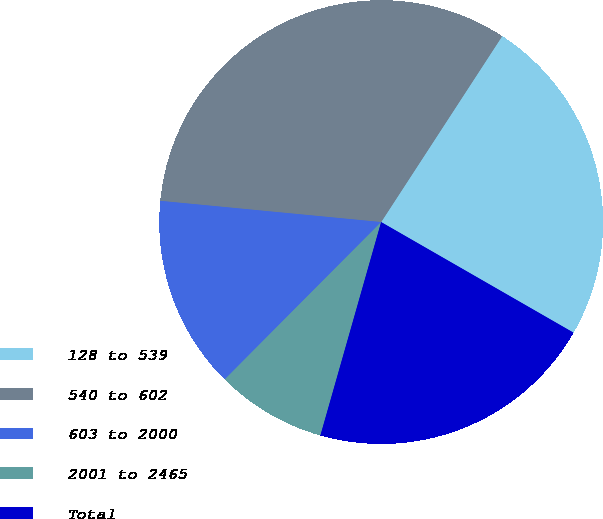Convert chart to OTSL. <chart><loc_0><loc_0><loc_500><loc_500><pie_chart><fcel>128 to 539<fcel>540 to 602<fcel>603 to 2000<fcel>2001 to 2465<fcel>Total<nl><fcel>24.12%<fcel>32.66%<fcel>14.07%<fcel>8.04%<fcel>21.11%<nl></chart> 